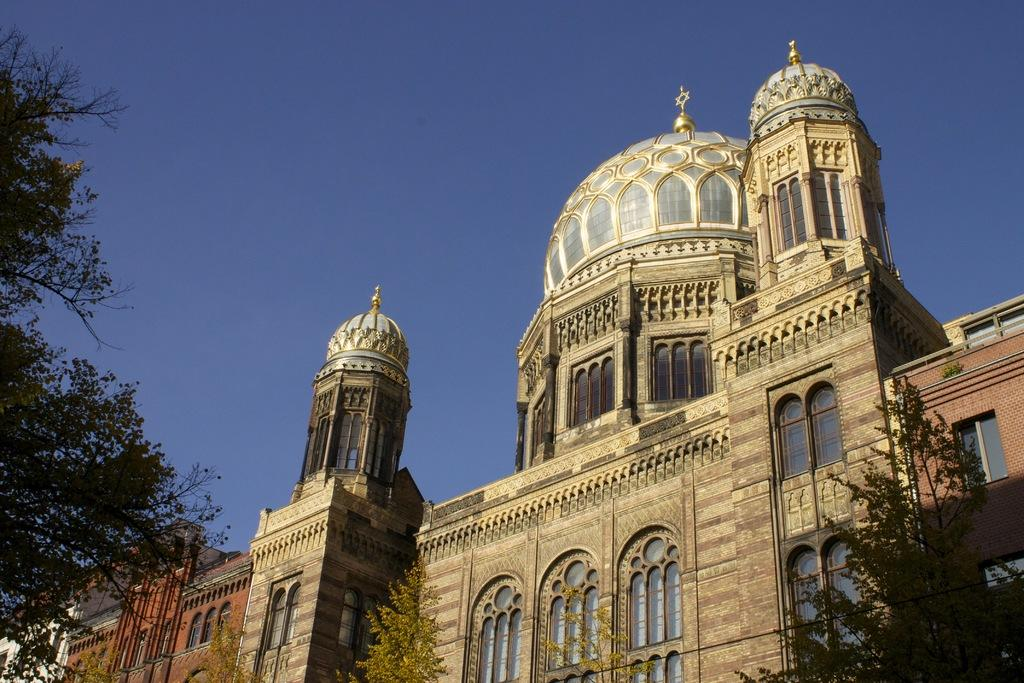What type of natural elements can be seen in the image? There are trees in the image. What type of man-made structures are present in the image? There are buildings in the image. What part of the natural environment is visible in the image? The sky is visible in the background of the image. What is the color of the sky in the image? The color of the sky is blue. What type of fear can be seen on the branches of the trees in the image? There is no fear present in the image, and trees do not have emotions or the ability to experience fear. 